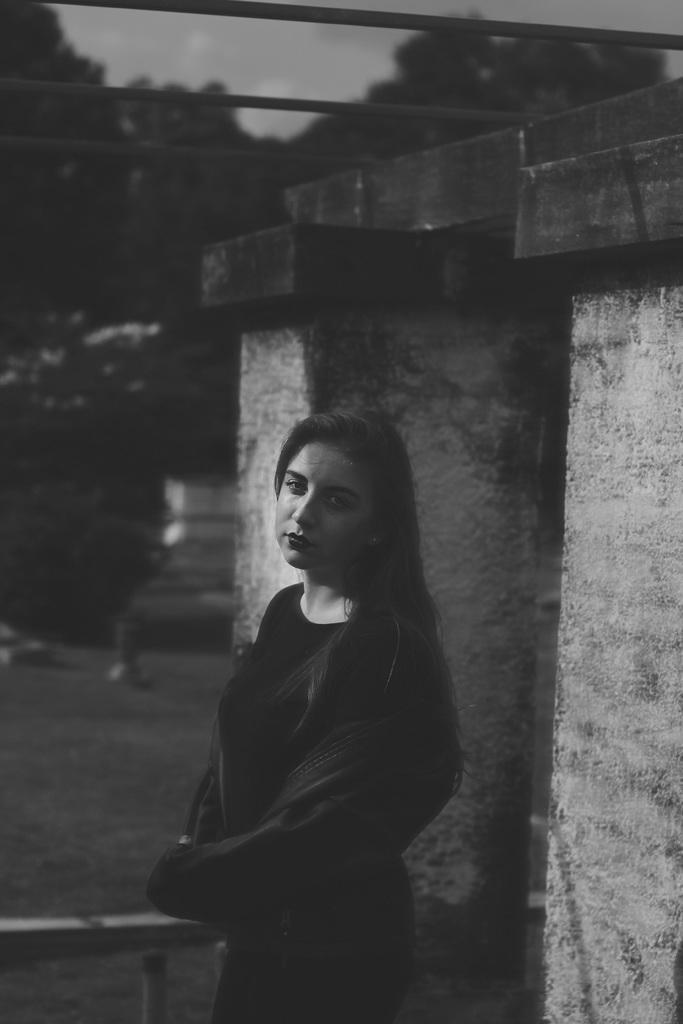In one or two sentences, can you explain what this image depicts? In this image there is a woman standing , and in the background there are trees,sky. 